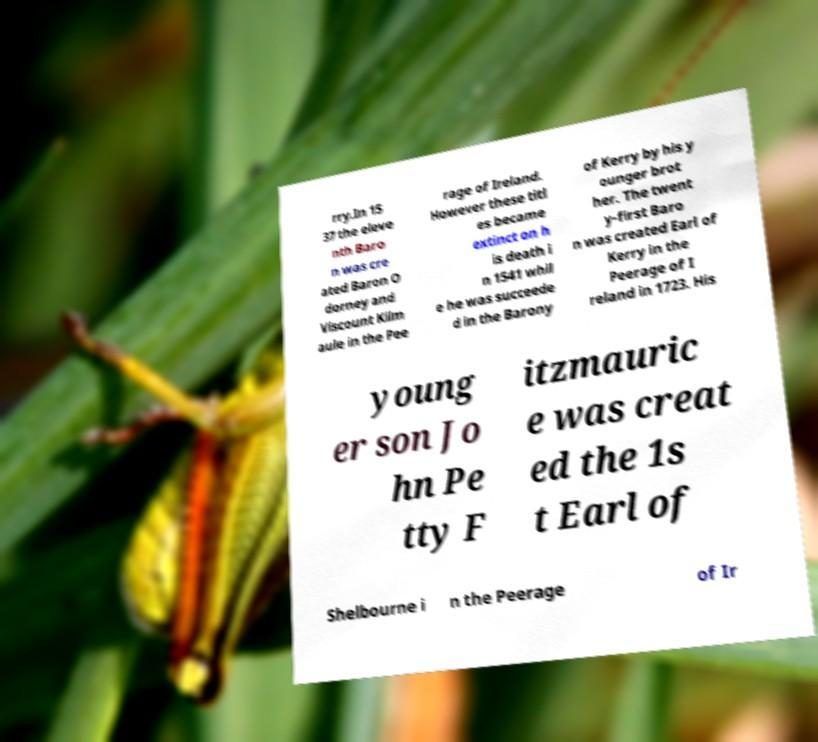For documentation purposes, I need the text within this image transcribed. Could you provide that? rry.In 15 37 the eleve nth Baro n was cre ated Baron O dorney and Viscount Kilm aule in the Pee rage of Ireland. However these titl es became extinct on h is death i n 1541 whil e he was succeede d in the Barony of Kerry by his y ounger brot her. The twent y-first Baro n was created Earl of Kerry in the Peerage of I reland in 1723. His young er son Jo hn Pe tty F itzmauric e was creat ed the 1s t Earl of Shelbourne i n the Peerage of Ir 